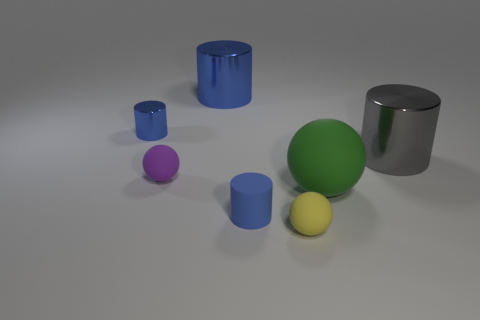Are there more small cylinders to the left of the purple thing than metal cylinders that are left of the big gray metal object?
Offer a terse response. No. Is there a large purple matte ball?
Ensure brevity in your answer.  No. What material is the large cylinder that is the same color as the small metallic thing?
Make the answer very short. Metal. How many things are either small blue rubber things or tiny brown matte blocks?
Your answer should be compact. 1. Is there a cylinder that has the same color as the small shiny object?
Ensure brevity in your answer.  Yes. What number of large rubber objects are behind the small matte ball that is on the left side of the yellow object?
Keep it short and to the point. 0. Are there more gray matte blocks than gray cylinders?
Provide a succinct answer. No. Does the green object have the same material as the purple ball?
Give a very brief answer. Yes. Is the number of small blue rubber cylinders in front of the tiny yellow matte sphere the same as the number of large green shiny things?
Make the answer very short. Yes. How many other cylinders are the same material as the big gray cylinder?
Your answer should be very brief. 2. 